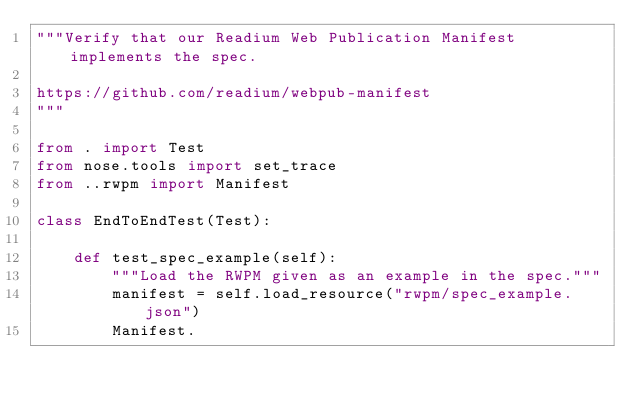Convert code to text. <code><loc_0><loc_0><loc_500><loc_500><_Python_>"""Verify that our Readium Web Publication Manifest implements the spec.

https://github.com/readium/webpub-manifest
"""

from . import Test
from nose.tools import set_trace
from ..rwpm import Manifest

class EndToEndTest(Test):

    def test_spec_example(self):
        """Load the RWPM given as an example in the spec."""
        manifest = self.load_resource("rwpm/spec_example.json")
        Manifest.

</code> 